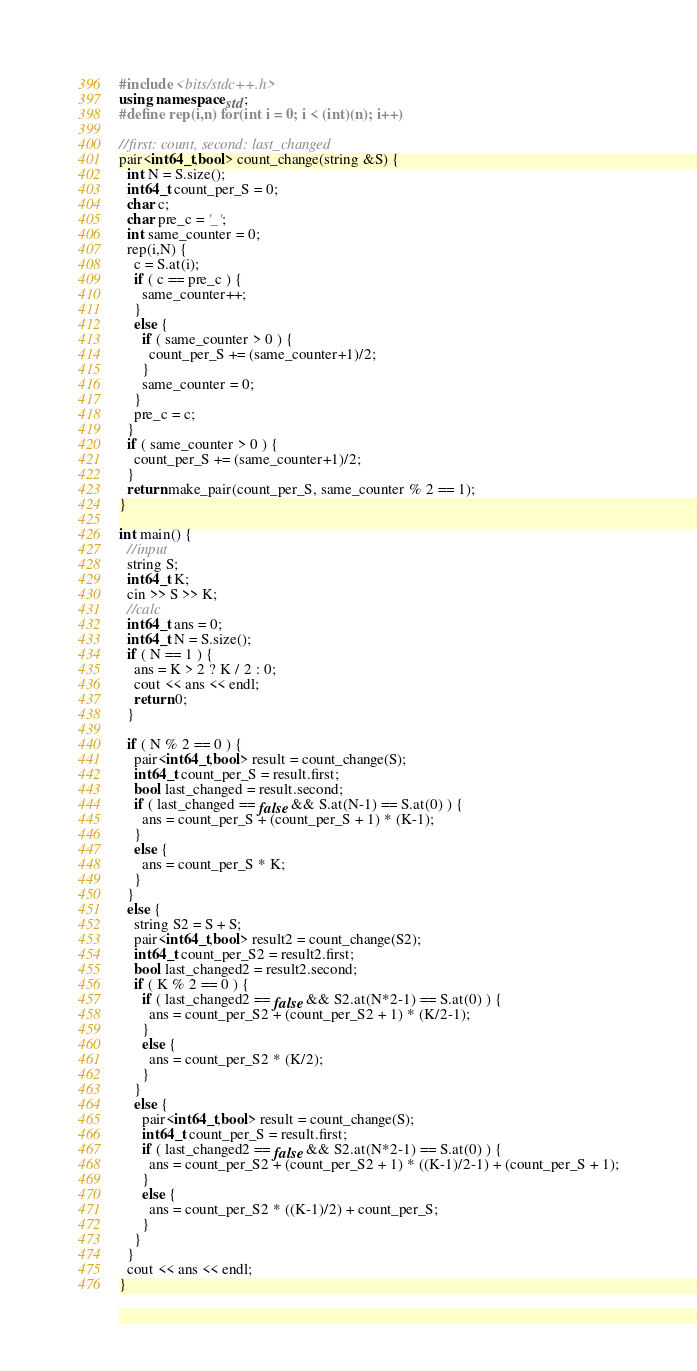<code> <loc_0><loc_0><loc_500><loc_500><_C++_>#include <bits/stdc++.h>
using namespace std;
#define rep(i,n) for(int i = 0; i < (int)(n); i++)

//first: count, second: last_changed
pair<int64_t,bool> count_change(string &S) {
  int N = S.size();
  int64_t count_per_S = 0;
  char c;
  char pre_c = '_';
  int same_counter = 0;
  rep(i,N) {
    c = S.at(i);
    if ( c == pre_c ) {
      same_counter++;
    }
    else {
      if ( same_counter > 0 ) {
        count_per_S += (same_counter+1)/2;
      }
      same_counter = 0;
    }
    pre_c = c;
  }
  if ( same_counter > 0 ) {
    count_per_S += (same_counter+1)/2;
  }
  return make_pair(count_per_S, same_counter % 2 == 1);
}

int main() {
  //input
  string S;
  int64_t K;
  cin >> S >> K;
  //calc
  int64_t ans = 0;
  int64_t N = S.size();
  if ( N == 1 ) {
    ans = K > 2 ? K / 2 : 0;
    cout << ans << endl;
    return 0;
  }

  if ( N % 2 == 0 ) {
    pair<int64_t,bool> result = count_change(S);
    int64_t count_per_S = result.first;
    bool last_changed = result.second;
    if ( last_changed == false && S.at(N-1) == S.at(0) ) {
      ans = count_per_S + (count_per_S + 1) * (K-1);
    }
    else {
      ans = count_per_S * K;
    }
  }
  else {
    string S2 = S + S;
    pair<int64_t,bool> result2 = count_change(S2);
    int64_t count_per_S2 = result2.first;
    bool last_changed2 = result2.second;
    if ( K % 2 == 0 ) {
      if ( last_changed2 == false && S2.at(N*2-1) == S.at(0) ) {
        ans = count_per_S2 + (count_per_S2 + 1) * (K/2-1);
      }
      else {
        ans = count_per_S2 * (K/2);
      }
    }
    else {
      pair<int64_t,bool> result = count_change(S);
      int64_t count_per_S = result.first;
      if ( last_changed2 == false && S2.at(N*2-1) == S.at(0) ) {
        ans = count_per_S2 + (count_per_S2 + 1) * ((K-1)/2-1) + (count_per_S + 1);
      }
      else {
        ans = count_per_S2 * ((K-1)/2) + count_per_S;
      }
    }
  }
  cout << ans << endl;
}</code> 